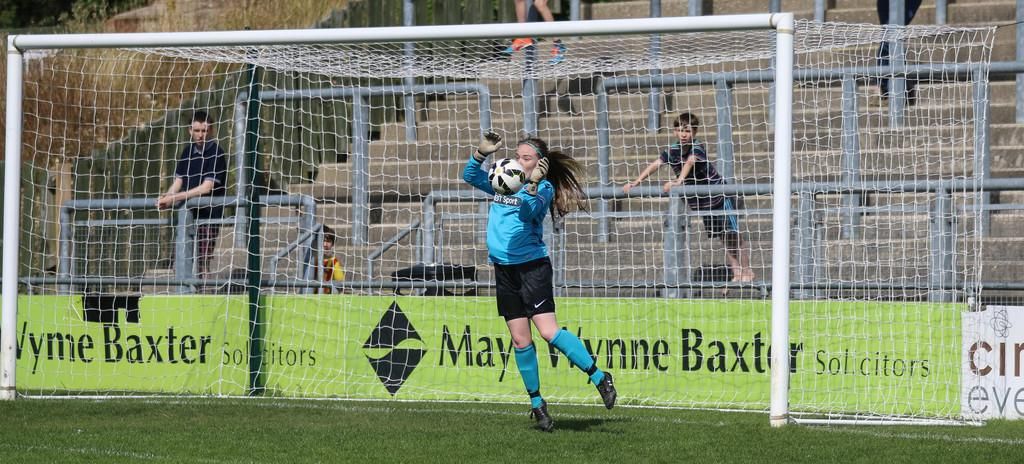<image>
Provide a brief description of the given image. A soccer goalie blocks the ball in front of an advertisement for Mary Wynne Baxter. 